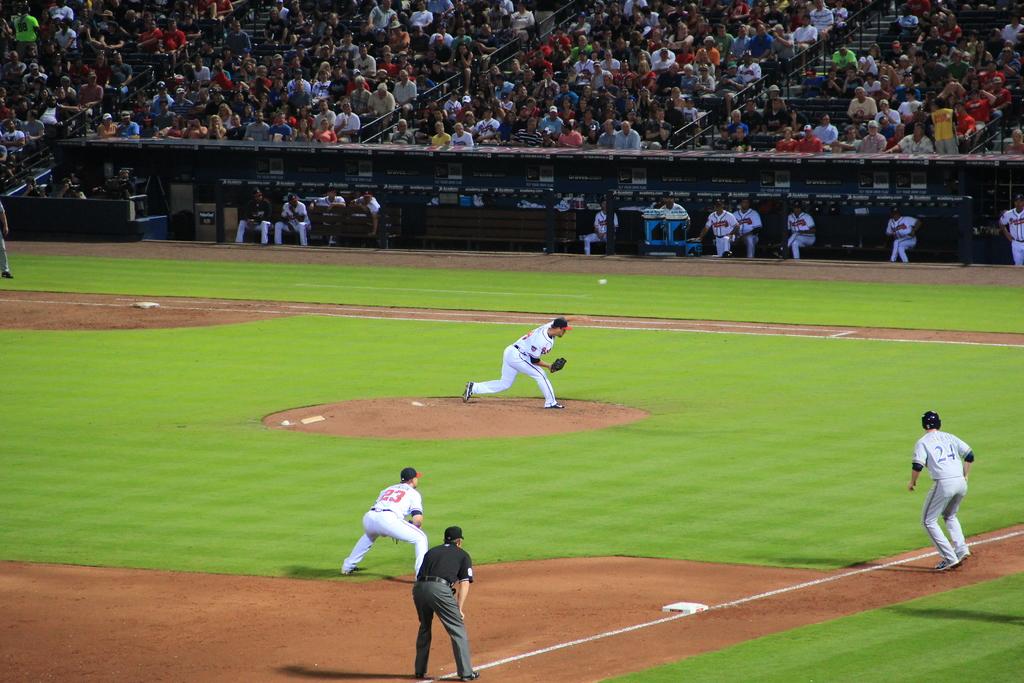What number is the baserunner?
Your answer should be very brief. 24. What player is the third baseman?
Give a very brief answer. 23. 